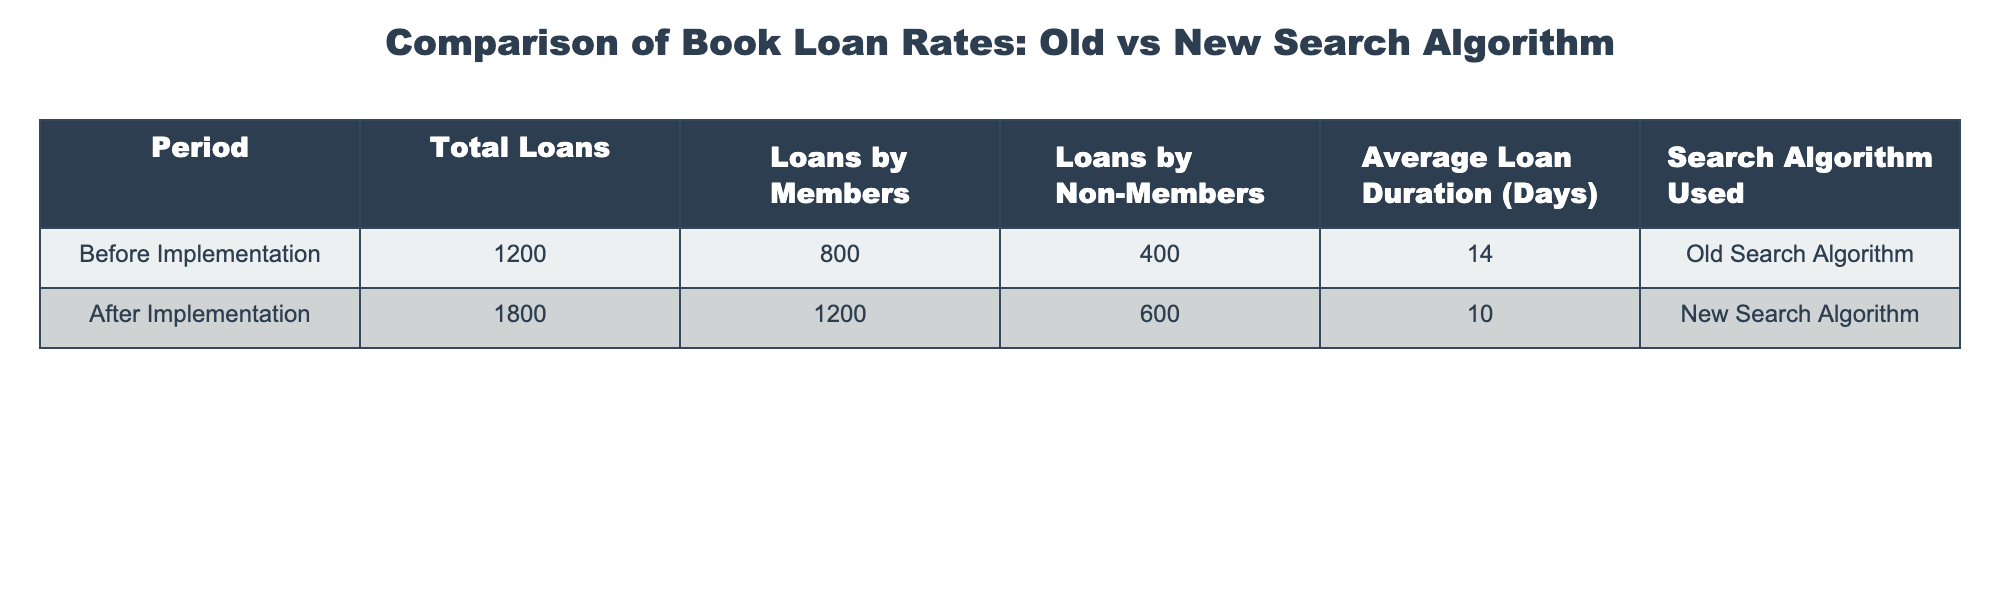What was the total number of loans after implementing the new search algorithm? In the "After Implementation" row, the "Total Loans" column shows a value of 1800. This value directly answers the question without any calculations needed.
Answer: 1800 What was the average loan duration before implementing the new search algorithm? In the "Before Implementation" row, the "Average Loan Duration (Days)" column shows a value of 14 days. Therefore, the average before the new algorithm was 14 days.
Answer: 14 days Did the number of loans by non-members increase after implementing the new search algorithm? The "Loans by Non-Members" column shows a value of 400 before the implementation and 600 after. Since 600 is greater than 400, it confirms an increase.
Answer: Yes What is the difference in total loans before and after implementation? To find the difference, subtract the total loans before (1200) from the total loans after (1800). Therefore, 1800 - 1200 equals 600.
Answer: 600 What was the percentage increase in loans by members after implementing the new algorithm? The number of loans by members increased from 800 to 1200. The increase is 1200 - 800 = 400. To find the percentage increase, divide by the original amount: (400 / 800) * 100 = 50%.
Answer: 50% What was the total loan duration in days for loans by members before and after the new algorithm? Before implementation, "Average Loan Duration" for loans by members is 14 days and the number of loans was 800, giving a total duration of 800 * 14 = 11200 days. After implementation, with an average of 10 days and 1200 loans, the total is 1200 * 10 = 12000 days. Therefore, the totals are 11200 days and 12000 days, respectively.
Answer: 11200 days (before), 12000 days (after) Was the average loan duration shorter after implementing the new search algorithm? The average loan duration before was 14 days and after it became 10 days. Since 10 is less than 14, it confirms that the duration was shorter.
Answer: Yes How many more loans by non-members were recorded after the new search algorithm was implemented compared to before? Loans by non-members increased from 400 to 600. The difference is calculated by subtracting the before value from the after value: 600 - 400 = 200.
Answer: 200 